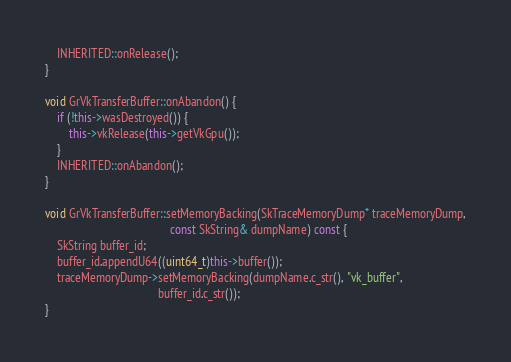Convert code to text. <code><loc_0><loc_0><loc_500><loc_500><_C++_>    INHERITED::onRelease();
}

void GrVkTransferBuffer::onAbandon() {
    if (!this->wasDestroyed()) {
        this->vkRelease(this->getVkGpu());
    }
    INHERITED::onAbandon();
}

void GrVkTransferBuffer::setMemoryBacking(SkTraceMemoryDump* traceMemoryDump,
                                          const SkString& dumpName) const {
    SkString buffer_id;
    buffer_id.appendU64((uint64_t)this->buffer());
    traceMemoryDump->setMemoryBacking(dumpName.c_str(), "vk_buffer",
                                      buffer_id.c_str());
}
</code> 